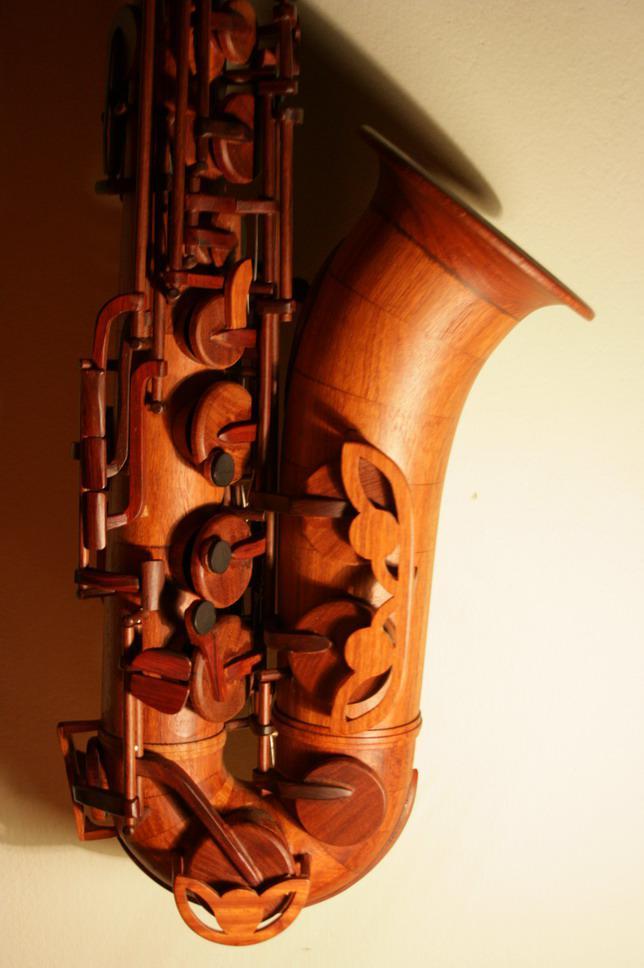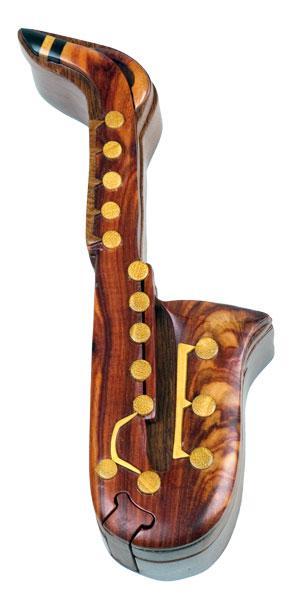The first image is the image on the left, the second image is the image on the right. For the images shown, is this caption "The right image features one wooden instrument on a white background." true? Answer yes or no. Yes. The first image is the image on the left, the second image is the image on the right. Assess this claim about the two images: "The image on the right contains a single saxophone on a white background.". Correct or not? Answer yes or no. Yes. The first image is the image on the left, the second image is the image on the right. Examine the images to the left and right. Is the description "At least one image has no background." accurate? Answer yes or no. Yes. 